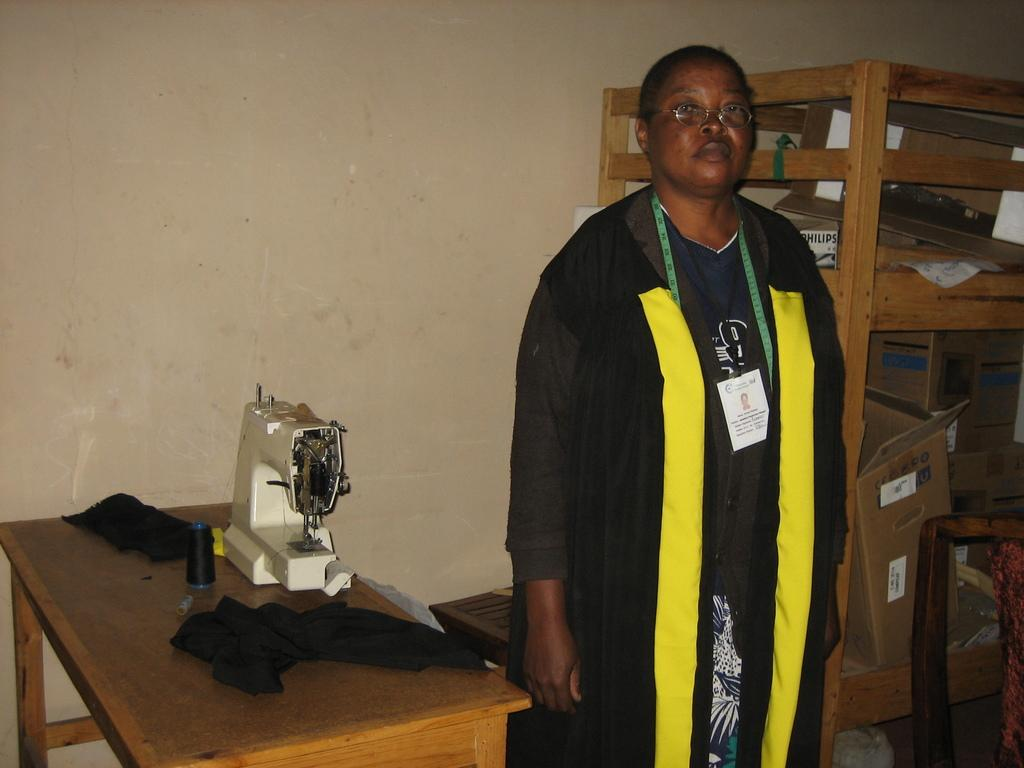Who is the main subject in the image? There is a lady in the image. What is the lady wearing? The lady is wearing a black coat. Can you describe any accessories the lady is wearing? The lady has a tape around her neck. What object is in front of the lady? There is a sewing machine in front of the lady. What can be seen behind the lady? There is a shelf behind the lady. What type of humor can be seen in the lady's facial expression in the image? There is no indication of humor or facial expression in the image; it only shows the lady wearing a black coat, a tape around her neck, and standing near a sewing machine and a shelf. 